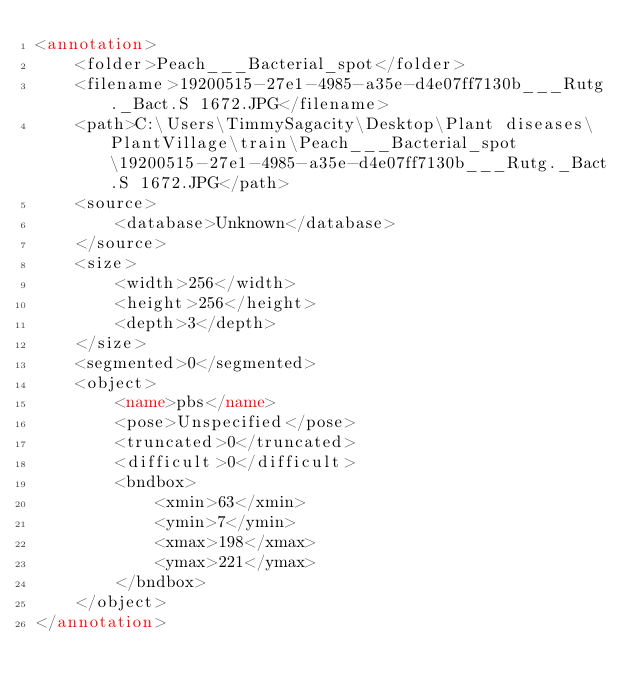<code> <loc_0><loc_0><loc_500><loc_500><_XML_><annotation>
	<folder>Peach___Bacterial_spot</folder>
	<filename>19200515-27e1-4985-a35e-d4e07ff7130b___Rutg._Bact.S 1672.JPG</filename>
	<path>C:\Users\TimmySagacity\Desktop\Plant diseases\PlantVillage\train\Peach___Bacterial_spot\19200515-27e1-4985-a35e-d4e07ff7130b___Rutg._Bact.S 1672.JPG</path>
	<source>
		<database>Unknown</database>
	</source>
	<size>
		<width>256</width>
		<height>256</height>
		<depth>3</depth>
	</size>
	<segmented>0</segmented>
	<object>
		<name>pbs</name>
		<pose>Unspecified</pose>
		<truncated>0</truncated>
		<difficult>0</difficult>
		<bndbox>
			<xmin>63</xmin>
			<ymin>7</ymin>
			<xmax>198</xmax>
			<ymax>221</ymax>
		</bndbox>
	</object>
</annotation>
</code> 